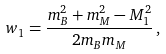Convert formula to latex. <formula><loc_0><loc_0><loc_500><loc_500>w _ { 1 } = \frac { m _ { B } ^ { 2 } + m _ { M } ^ { 2 } - M _ { 1 } ^ { 2 } } { 2 m _ { B } m _ { M } } \, ,</formula> 